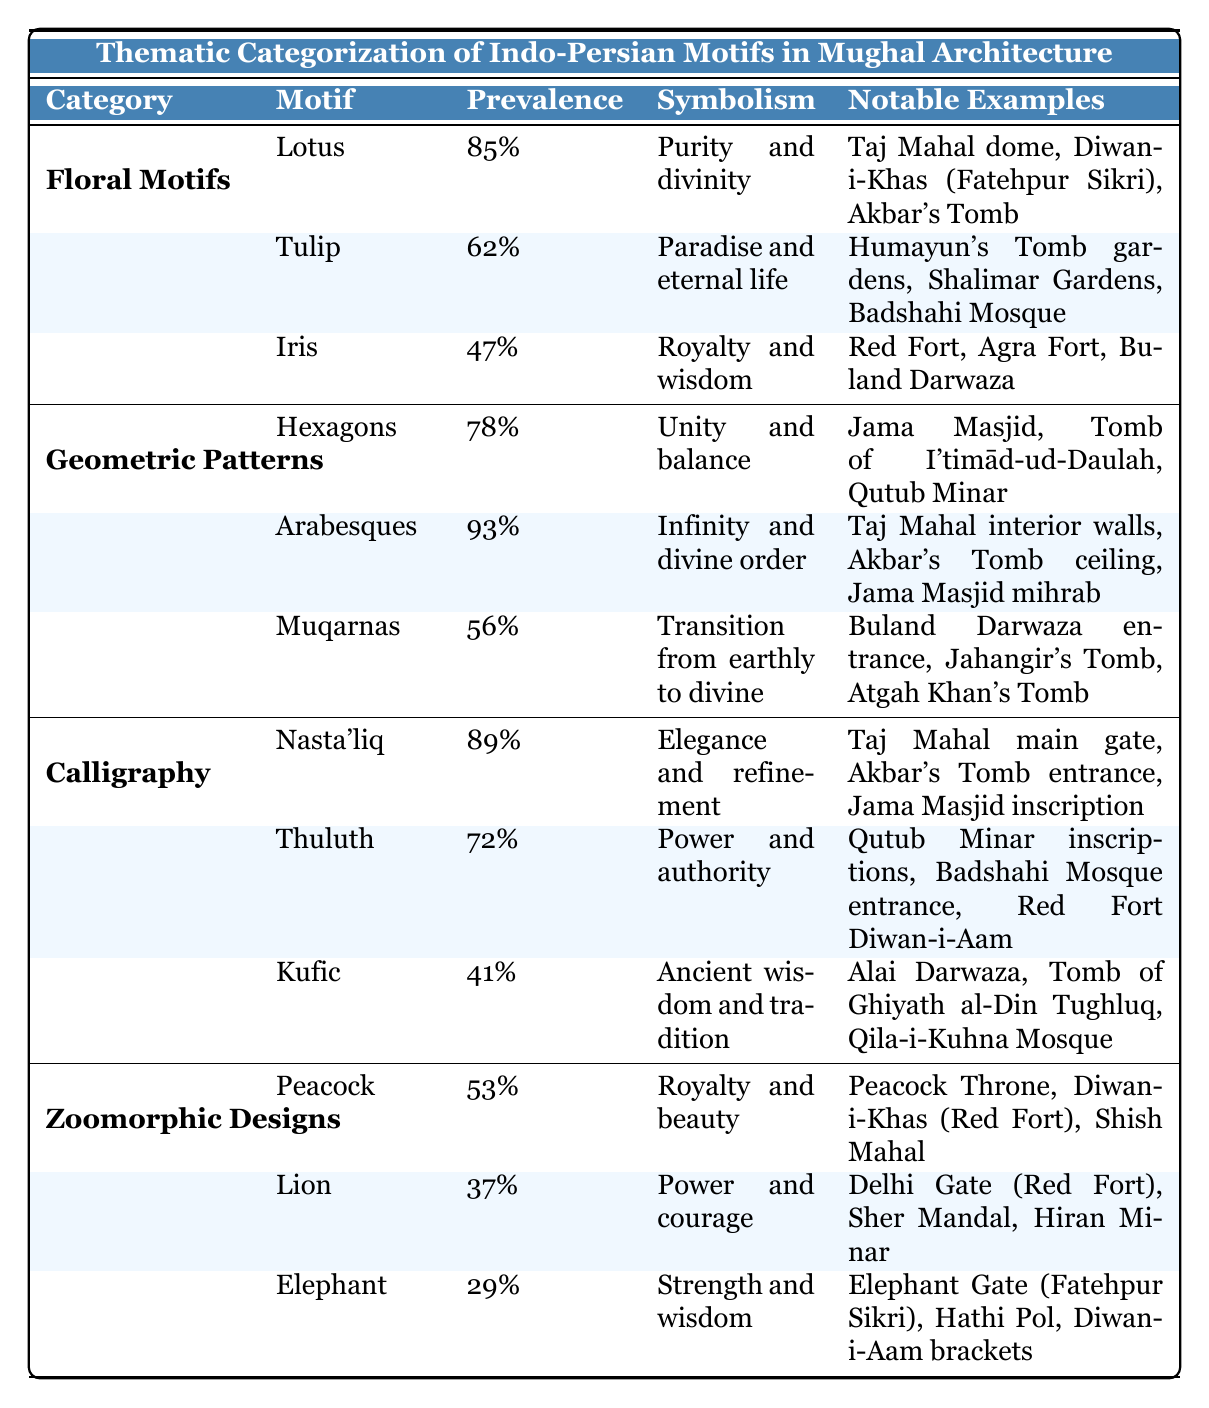What is the most prevalent floral motif in Mughal architecture? Among the floral motifs listed in the table, the Lotus has the highest prevalence at 85%.
Answer: Lotus Which geometric pattern has the highest symbolism and what is it? The Arabesques pattern has the highest prevalence (93%) and symbolizes infinity and divine order.
Answer: Arabesques, infinity and divine order How many motifs have a prevalence greater than 70%? Reviewing the table, the following motifs have a prevalence greater than 70%: Lotus (85%), Arabesques (93%), and Nasta'liq (89%). That makes a total of 3 motifs.
Answer: 3 Is there any zoomorphic design motif that symbolizes 'strength and wisdom'? Yes, the Elephant motif symbolizes strength and wisdom, as indicated in the table.
Answer: Yes Which floral motif is associated with 'royalty and wisdom'? The Iris floral motif is associated with royalty and wisdom.
Answer: Iris What is the average prevalence of the geometric patterns listed in the table? To find the average, we sum the prevalence of the geometric patterns: Hexagons (78%), Arabesques (93%), Muqarnas (56%), which totals to 227%. Dividing by 3 gives us an average of 75.67%.
Answer: 75.67% Which calligraphic motif is least prevalent, and what is its percentage? The Kufic calligraphic motif is the least prevalent with a value of 41%.
Answer: Kufic, 41% What is the total prevalence of floral motifs combined? Adding the prevalence of all floral motifs: Lotus (85%), Tulip (62%), Iris (47%) gives us a total of 194%.
Answer: 194% Which two motifs have the same prevalence of 62%? The Tulip is the only motif with a prevalence of 62%, so there is no second motif that matches this value in the categories listed.
Answer: No Is it true that all zoomorphic designs symbolize royal attributes? Not all zoomorphic designs symbolize royal attributes; for example, the Lion symbolizes power and courage, while the Elephant symbolizes strength and wisdom.
Answer: No 